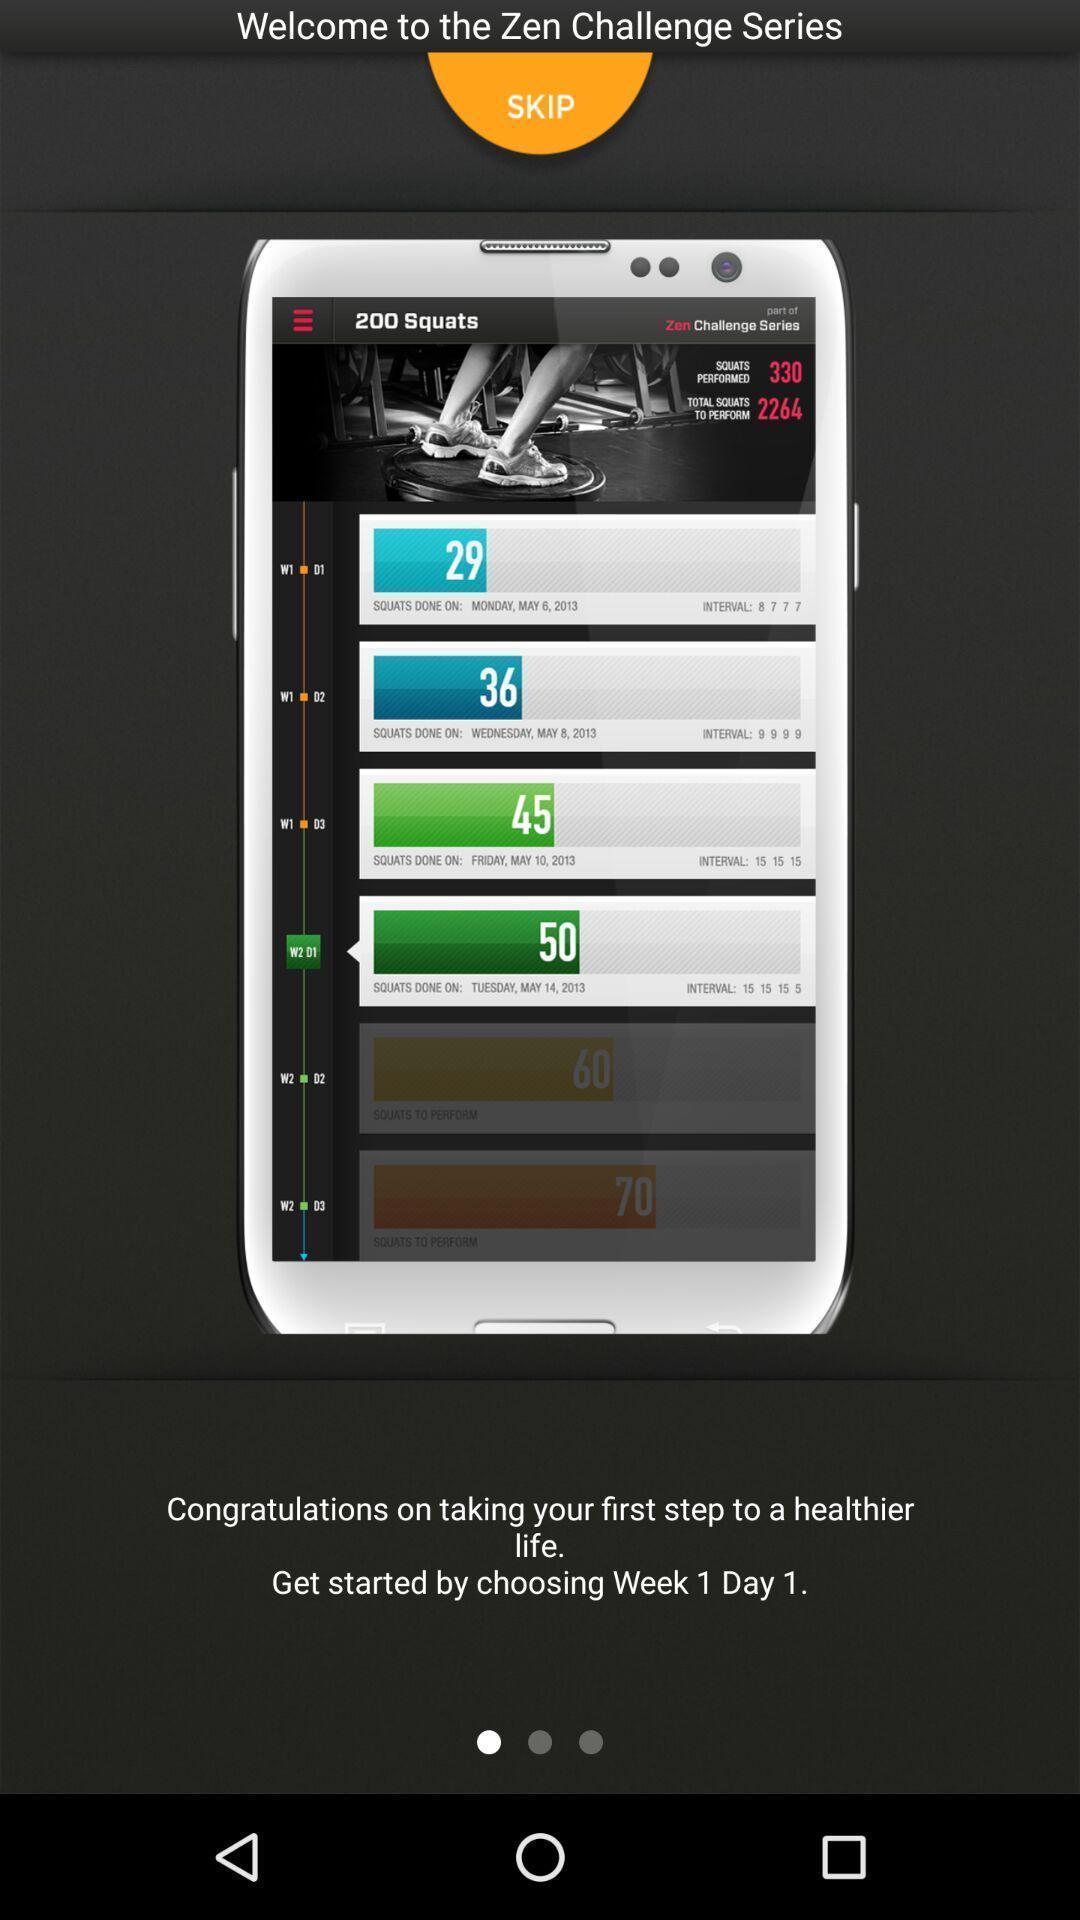Provide a textual representation of this image. Welcome screen. 